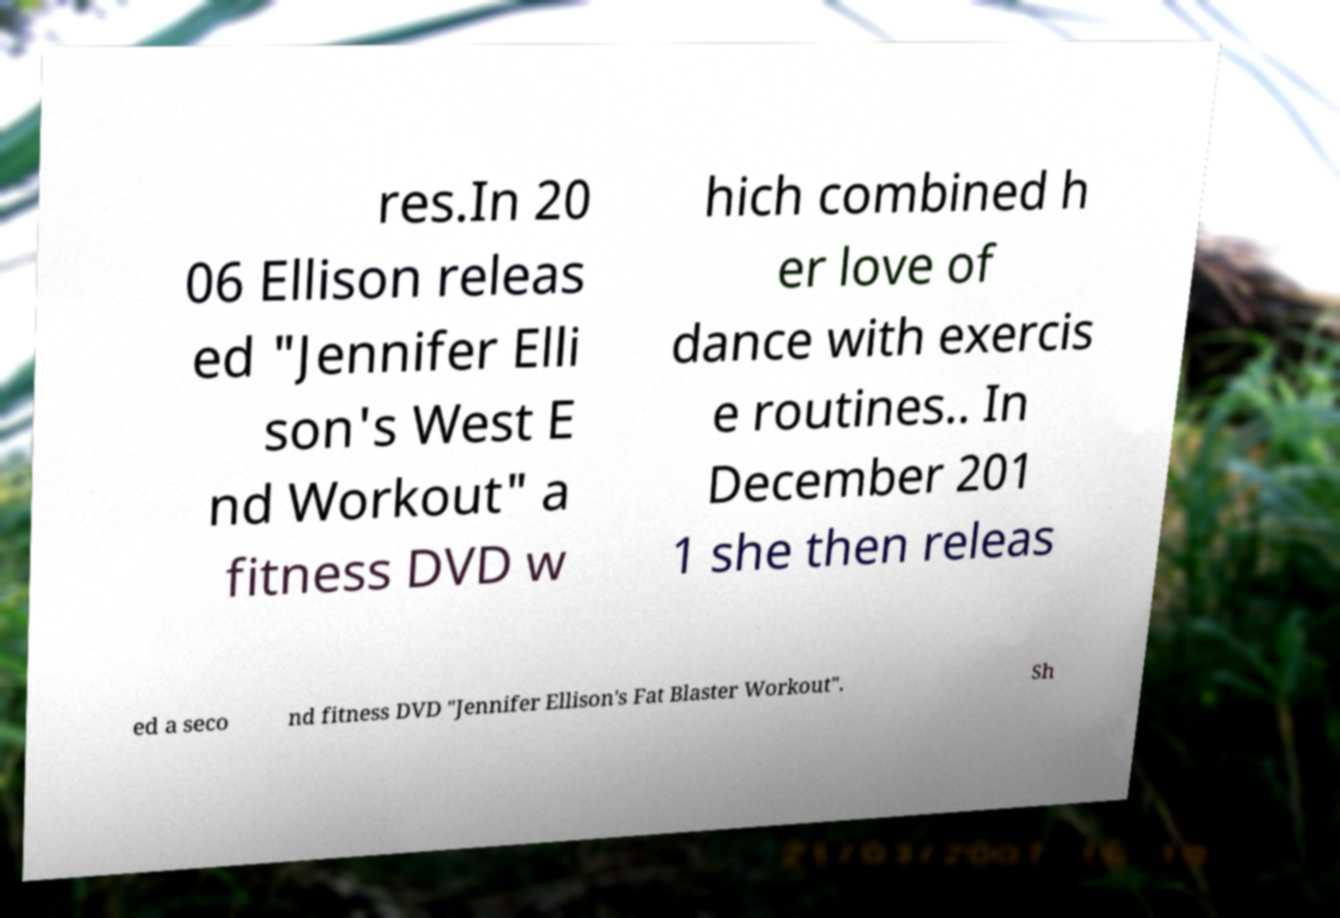Please read and relay the text visible in this image. What does it say? res.In 20 06 Ellison releas ed "Jennifer Elli son's West E nd Workout" a fitness DVD w hich combined h er love of dance with exercis e routines.. In December 201 1 she then releas ed a seco nd fitness DVD "Jennifer Ellison's Fat Blaster Workout". Sh 